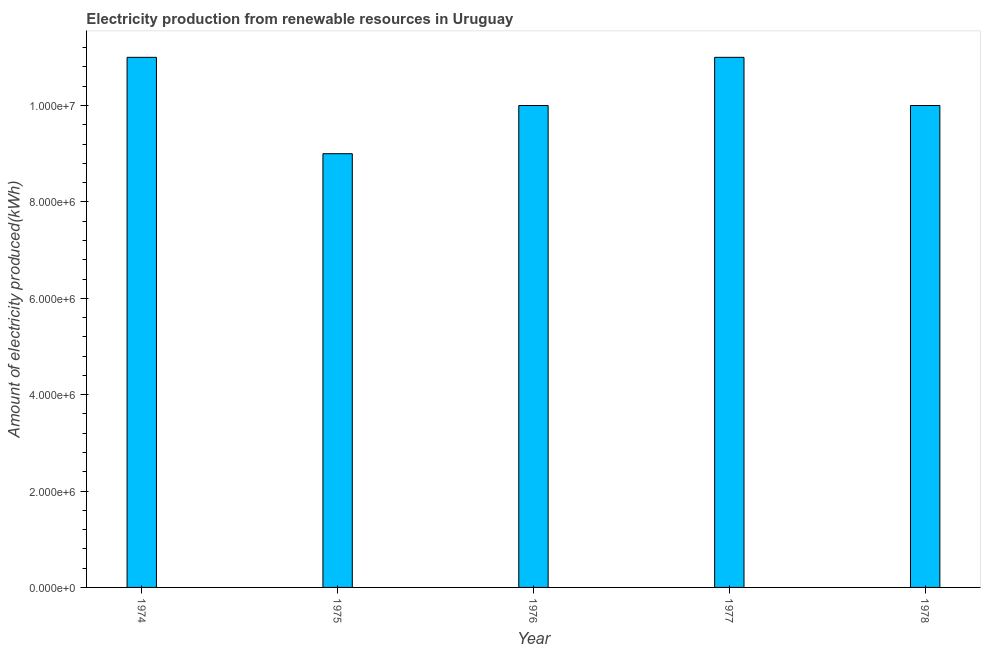Does the graph contain any zero values?
Give a very brief answer. No. What is the title of the graph?
Keep it short and to the point. Electricity production from renewable resources in Uruguay. What is the label or title of the X-axis?
Make the answer very short. Year. What is the label or title of the Y-axis?
Your answer should be very brief. Amount of electricity produced(kWh). What is the amount of electricity produced in 1977?
Provide a succinct answer. 1.10e+07. Across all years, what is the maximum amount of electricity produced?
Make the answer very short. 1.10e+07. Across all years, what is the minimum amount of electricity produced?
Provide a short and direct response. 9.00e+06. In which year was the amount of electricity produced maximum?
Your response must be concise. 1974. In which year was the amount of electricity produced minimum?
Offer a terse response. 1975. What is the sum of the amount of electricity produced?
Your answer should be very brief. 5.10e+07. What is the average amount of electricity produced per year?
Provide a succinct answer. 1.02e+07. What is the median amount of electricity produced?
Provide a succinct answer. 1.00e+07. Do a majority of the years between 1976 and 1975 (inclusive) have amount of electricity produced greater than 2400000 kWh?
Offer a very short reply. No. Is the amount of electricity produced in 1974 less than that in 1976?
Your answer should be compact. No. What is the difference between the highest and the second highest amount of electricity produced?
Provide a succinct answer. 0. What is the difference between the highest and the lowest amount of electricity produced?
Your answer should be compact. 2.00e+06. In how many years, is the amount of electricity produced greater than the average amount of electricity produced taken over all years?
Make the answer very short. 2. How many bars are there?
Your response must be concise. 5. How many years are there in the graph?
Provide a short and direct response. 5. Are the values on the major ticks of Y-axis written in scientific E-notation?
Give a very brief answer. Yes. What is the Amount of electricity produced(kWh) of 1974?
Offer a terse response. 1.10e+07. What is the Amount of electricity produced(kWh) of 1975?
Provide a short and direct response. 9.00e+06. What is the Amount of electricity produced(kWh) in 1977?
Keep it short and to the point. 1.10e+07. What is the difference between the Amount of electricity produced(kWh) in 1974 and 1978?
Keep it short and to the point. 1.00e+06. What is the difference between the Amount of electricity produced(kWh) in 1975 and 1977?
Your response must be concise. -2.00e+06. What is the difference between the Amount of electricity produced(kWh) in 1975 and 1978?
Provide a succinct answer. -1.00e+06. What is the difference between the Amount of electricity produced(kWh) in 1976 and 1977?
Make the answer very short. -1.00e+06. What is the difference between the Amount of electricity produced(kWh) in 1976 and 1978?
Make the answer very short. 0. What is the difference between the Amount of electricity produced(kWh) in 1977 and 1978?
Ensure brevity in your answer.  1.00e+06. What is the ratio of the Amount of electricity produced(kWh) in 1974 to that in 1975?
Keep it short and to the point. 1.22. What is the ratio of the Amount of electricity produced(kWh) in 1974 to that in 1978?
Your answer should be compact. 1.1. What is the ratio of the Amount of electricity produced(kWh) in 1975 to that in 1977?
Your response must be concise. 0.82. What is the ratio of the Amount of electricity produced(kWh) in 1975 to that in 1978?
Offer a very short reply. 0.9. What is the ratio of the Amount of electricity produced(kWh) in 1976 to that in 1977?
Your answer should be compact. 0.91. 